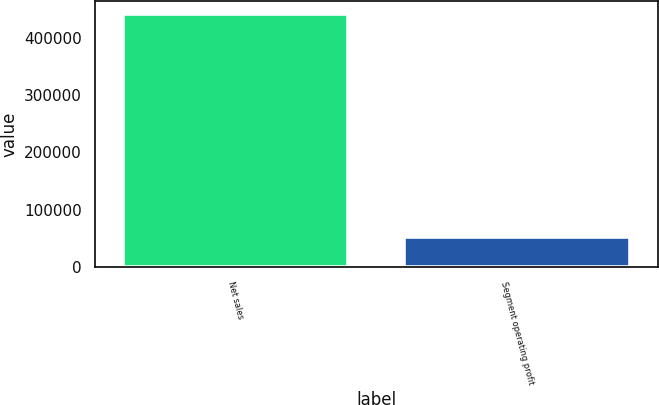Convert chart. <chart><loc_0><loc_0><loc_500><loc_500><bar_chart><fcel>Net sales<fcel>Segment operating profit<nl><fcel>442763<fcel>52608<nl></chart> 